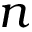<formula> <loc_0><loc_0><loc_500><loc_500>n</formula> 